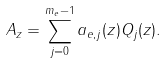Convert formula to latex. <formula><loc_0><loc_0><loc_500><loc_500>A _ { z } = \sum _ { j = 0 } ^ { m _ { e } - 1 } a _ { e , j } ( z ) Q _ { j } ( z ) .</formula> 